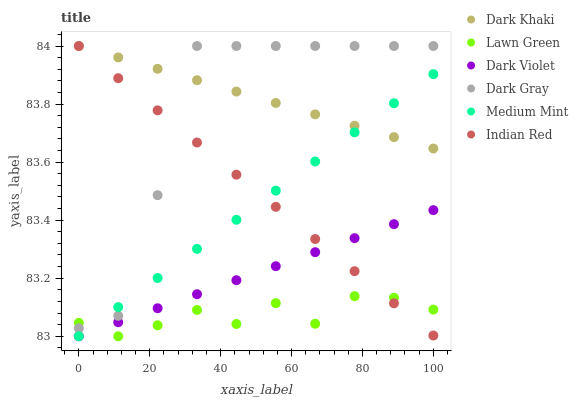Does Lawn Green have the minimum area under the curve?
Answer yes or no. Yes. Does Dark Khaki have the maximum area under the curve?
Answer yes or no. Yes. Does Dark Violet have the minimum area under the curve?
Answer yes or no. No. Does Dark Violet have the maximum area under the curve?
Answer yes or no. No. Is Indian Red the smoothest?
Answer yes or no. Yes. Is Dark Gray the roughest?
Answer yes or no. Yes. Is Lawn Green the smoothest?
Answer yes or no. No. Is Lawn Green the roughest?
Answer yes or no. No. Does Medium Mint have the lowest value?
Answer yes or no. Yes. Does Dark Khaki have the lowest value?
Answer yes or no. No. Does Indian Red have the highest value?
Answer yes or no. Yes. Does Dark Violet have the highest value?
Answer yes or no. No. Is Dark Violet less than Dark Khaki?
Answer yes or no. Yes. Is Dark Khaki greater than Lawn Green?
Answer yes or no. Yes. Does Indian Red intersect Dark Violet?
Answer yes or no. Yes. Is Indian Red less than Dark Violet?
Answer yes or no. No. Is Indian Red greater than Dark Violet?
Answer yes or no. No. Does Dark Violet intersect Dark Khaki?
Answer yes or no. No. 